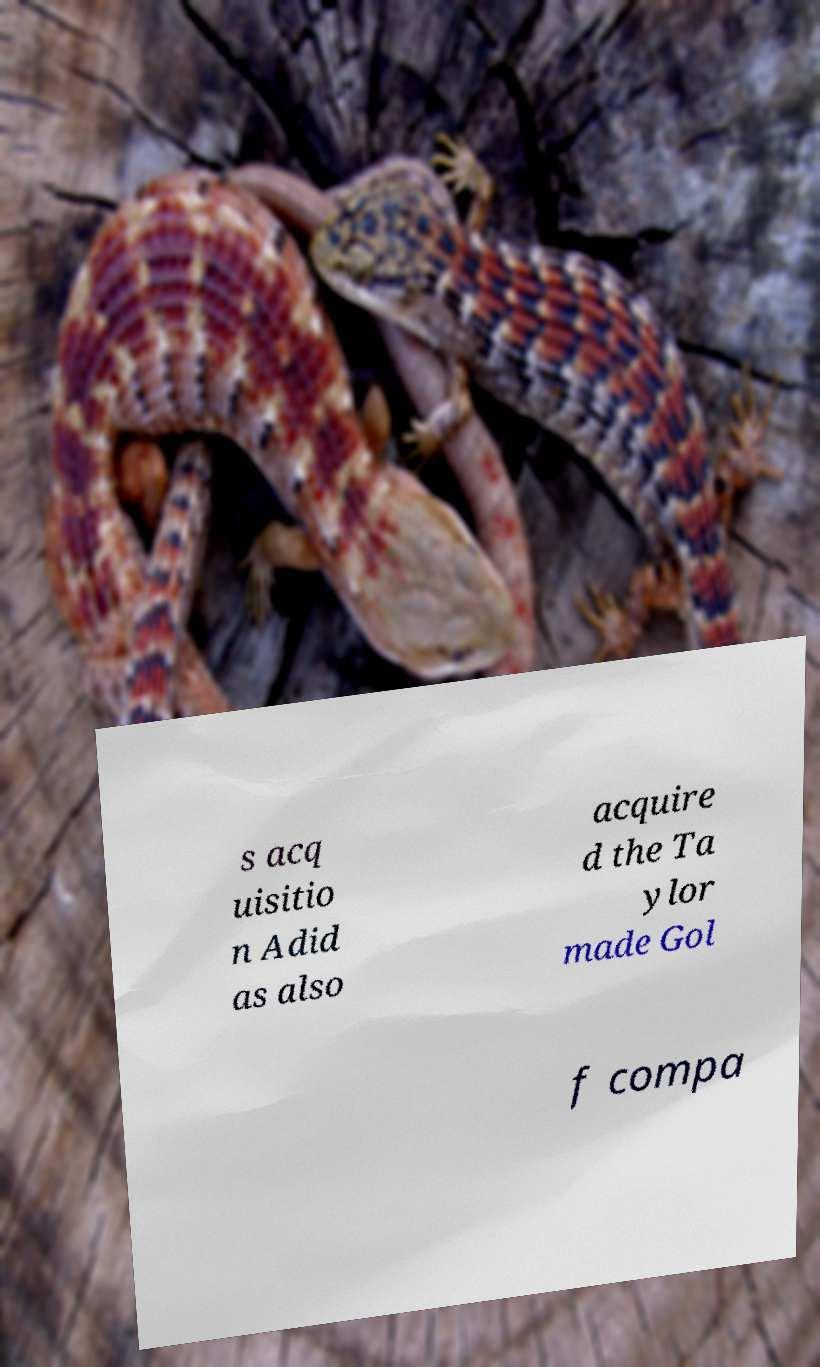Could you assist in decoding the text presented in this image and type it out clearly? s acq uisitio n Adid as also acquire d the Ta ylor made Gol f compa 